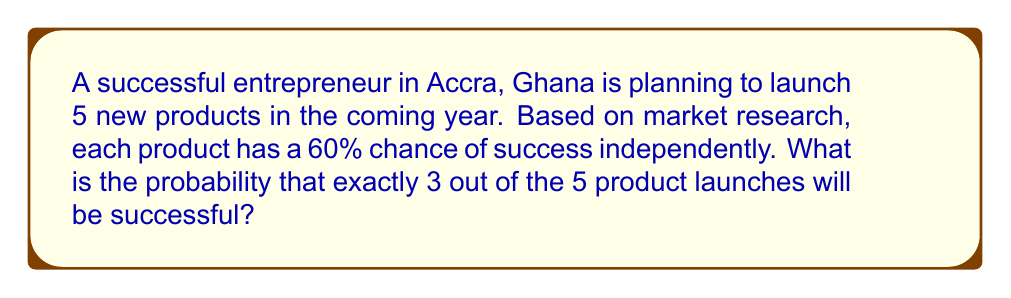Show me your answer to this math problem. To solve this problem, we can use the binomial probability formula, which is a combinatorial approach to calculating probabilities for a fixed number of independent trials with two possible outcomes (success or failure).

The binomial probability formula is:

$$P(X = k) = \binom{n}{k} p^k (1-p)^{n-k}$$

Where:
$n$ = total number of trials
$k$ = number of successes
$p$ = probability of success on each trial

In this case:
$n = 5$ (total number of product launches)
$k = 3$ (number of successful launches we're interested in)
$p = 0.60$ (60% chance of success for each product)

Let's calculate step by step:

1) First, we need to calculate $\binom{5}{3}$:
   $$\binom{5}{3} = \frac{5!}{3!(5-3)!} = \frac{5!}{3!2!} = 10$$

2) Now, let's substitute all values into the formula:
   $$P(X = 3) = 10 \cdot (0.60)^3 \cdot (1-0.60)^{5-3}$$

3) Simplify:
   $$P(X = 3) = 10 \cdot (0.60)^3 \cdot (0.40)^2$$

4) Calculate:
   $$P(X = 3) = 10 \cdot 0.216 \cdot 0.16 = 0.3456$$

Therefore, the probability of exactly 3 out of 5 product launches being successful is 0.3456 or 34.56%.
Answer: The probability is 0.3456 or 34.56%. 